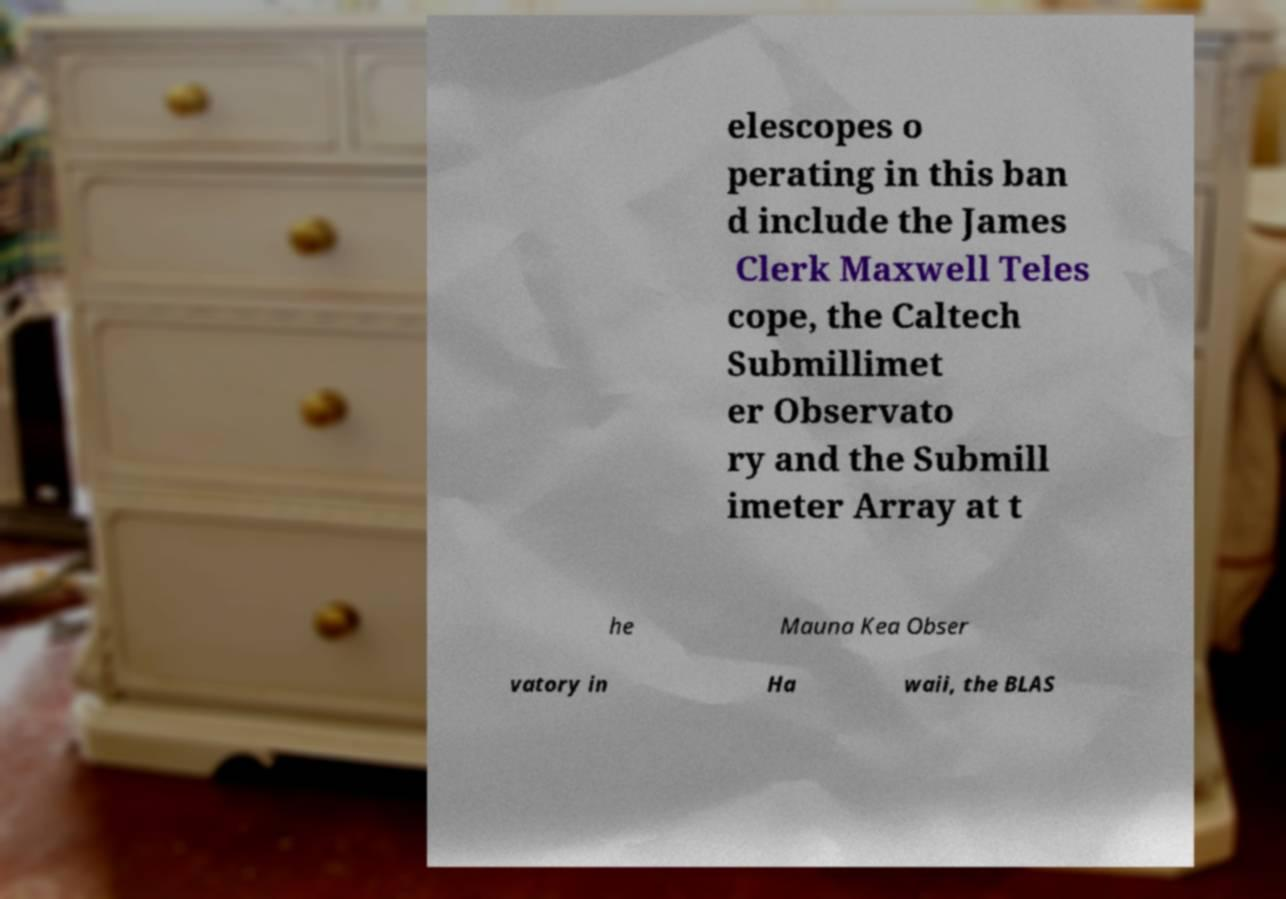Please read and relay the text visible in this image. What does it say? elescopes o perating in this ban d include the James Clerk Maxwell Teles cope, the Caltech Submillimet er Observato ry and the Submill imeter Array at t he Mauna Kea Obser vatory in Ha waii, the BLAS 